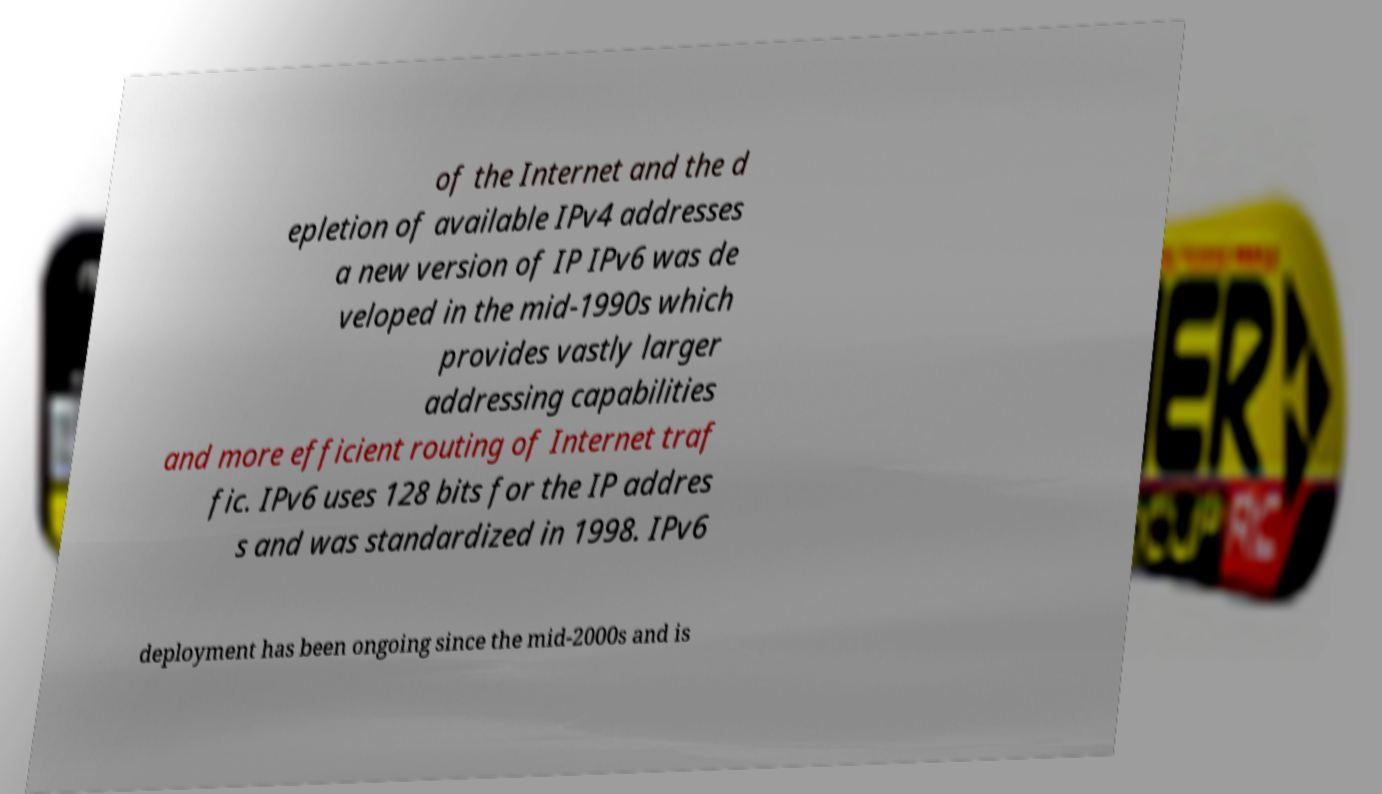Could you extract and type out the text from this image? of the Internet and the d epletion of available IPv4 addresses a new version of IP IPv6 was de veloped in the mid-1990s which provides vastly larger addressing capabilities and more efficient routing of Internet traf fic. IPv6 uses 128 bits for the IP addres s and was standardized in 1998. IPv6 deployment has been ongoing since the mid-2000s and is 